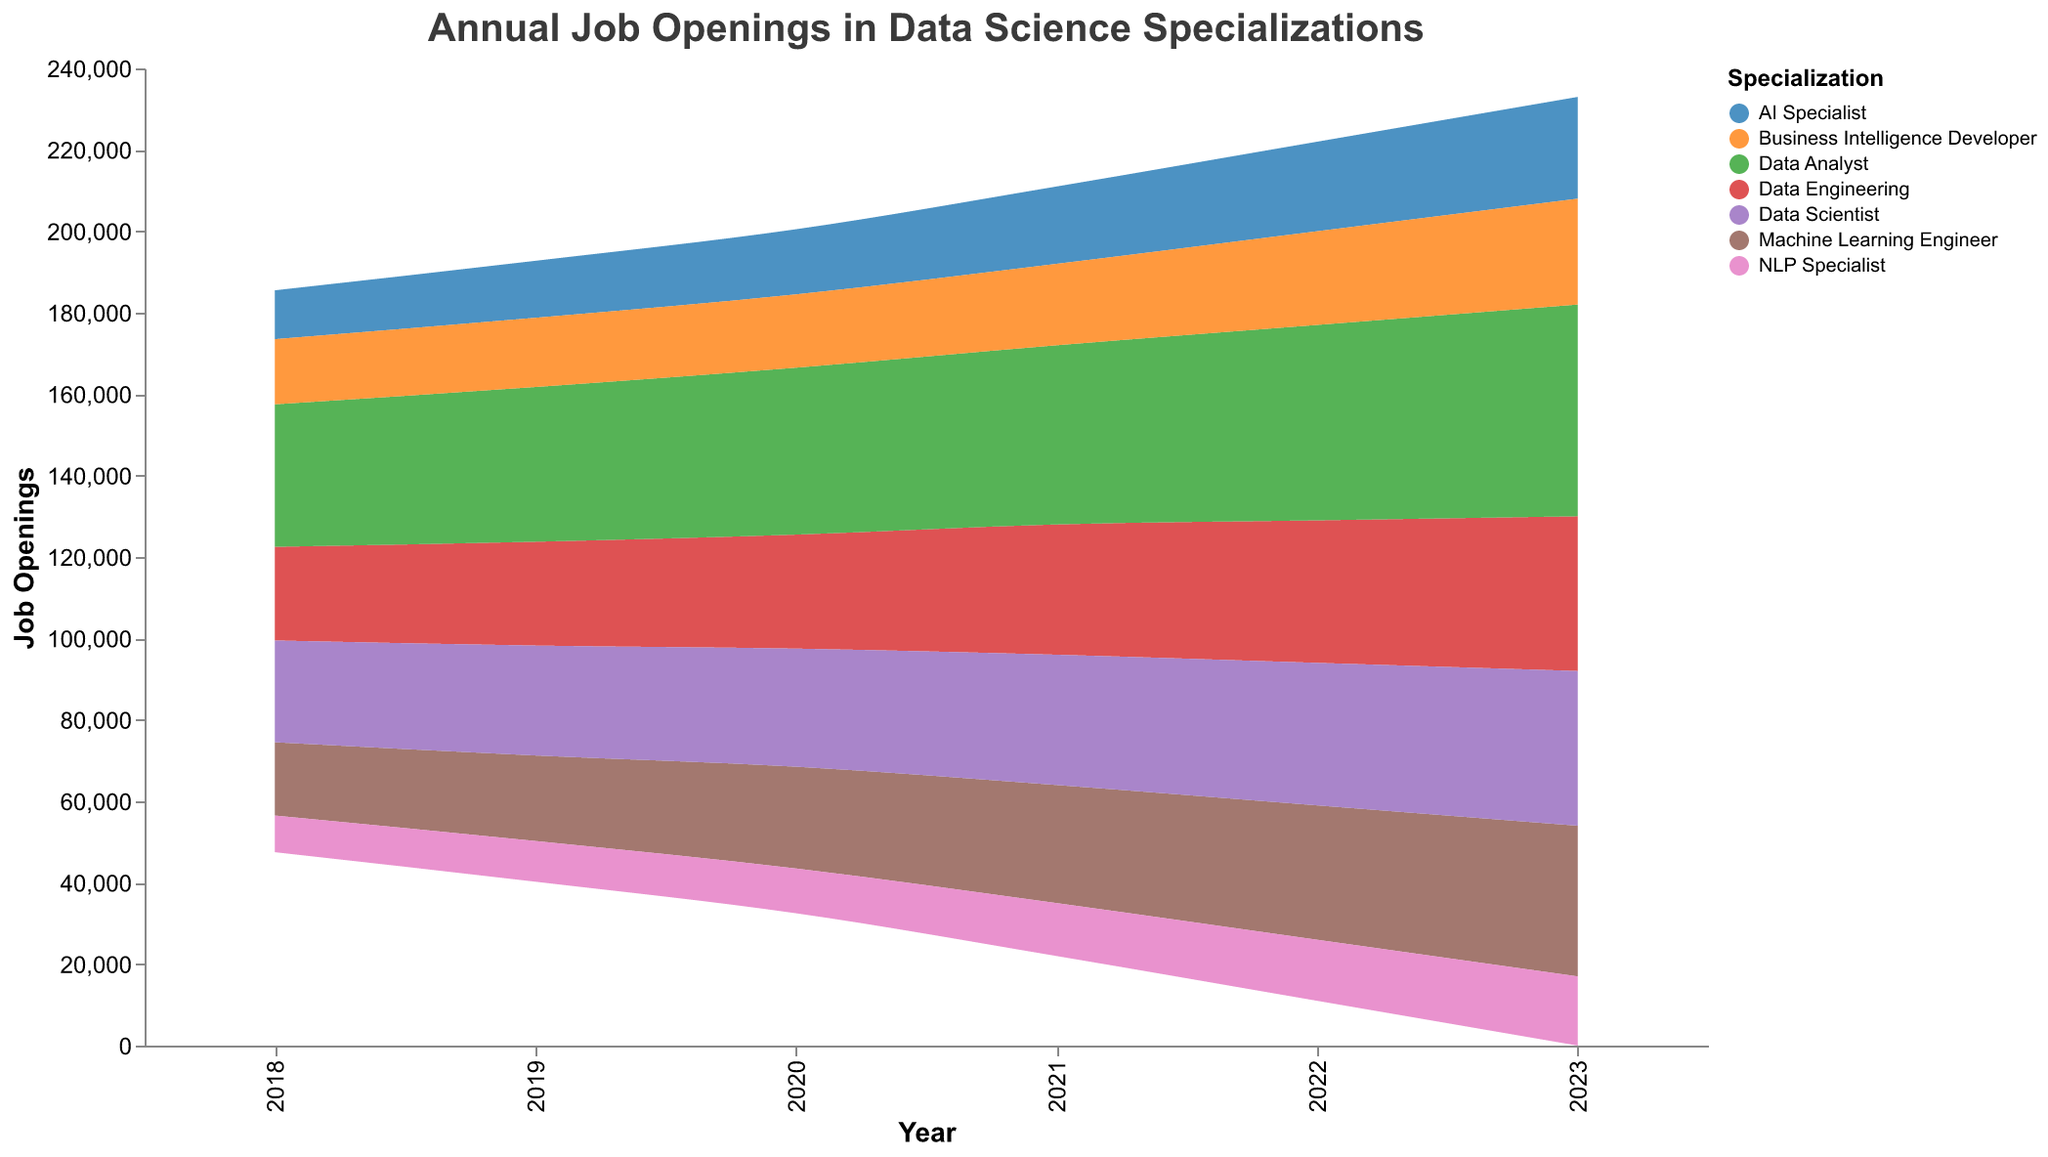What is the title of the figure? The title is often written at the top of the figure with large and bold font. In this case, it reads "Annual Job Openings in Data Science Specializations".
Answer: Annual Job Openings in Data Science Specializations Which specialization had the highest number of job openings in 2023? The different color bands represent different specializations, and their heights indicate the number of job openings. In 2023, the Data Analyst specialization has the largest area, indicating the highest number of job openings.
Answer: Data Analyst How has the job opening trend for AI Specialists changed from 2018 to 2023? By following the color band representing AI Specialists from 2018 to 2023, we see a steady increase. This can be verified by the visualization's upward trend for the AI Specialist color band.
Answer: Increased Compare the job openings for Data Engineers and Data Scientists in 2021. Which one is higher? Locate the two color bands for Data Engineers and Data Scientists in 2021. The color band for Data Science is slightly higher than Data Engineering, indicating more job openings.
Answer: Data Scientist Calculate the total number of job openings for all specializations in 2022? Sum up the values for all specializations in the year 2022 from the figure. The values are: Data Engineering (35,000), Machine Learning Engineer (33,000), Data Analyst (48,000), Data Scientist (35,000), AI Specialist (22,000), NLP Specialist (15,000), Business Intelligence Developer (23,000). Adding these, the total is 211,000.
Answer: 211,000 How did the relative growth rate for Data Engineers compare to that for NLP Specialists from 2021 to 2022? Check the growth rates for Data Engineers and NLP Specialists from 2021 to 2022. Data Engineers had a growth rate of 9.38%, while NLP Specialists had a growth rate of 15.38%. NLP Specialists had a higher growth rate.
Answer: NLP Specialists had a higher growth rate Which specialization had the lowest growth rate in 2020? The year-to-year growth rates for each specialization are provided. For 2020, the lowest growth rate can be observed for Business Intelligence Developer, which had only a 5.88% growth rate.
Answer: Business Intelligence Developer What is the difference in job openings between Data Analysts and Machine Learning Engineers in 2019? Locate the Data Analyst and Machine Learning Engineer job openings for 2019. Subtract the number of job openings for Machine Learning Engineer (21,000) from the number for Data Analyst (38,000). The difference is 17,000.
Answer: 17,000 Which specialization sees the most consistent growth in job openings from 2018 to 2023? By visually examining the color bands over the years from 2018 to 2023, Machine Learning Engineers exhibit a consistent growth pattern with annual increases.
Answer: Machine Learning Engineer How does the visual area of the AI Specialist band in 2018 compare to 2023? Compare the height and width of the AI Specialist color band between 2018 and 2023. The visual area in 2023 is much larger, indicating an increase in job openings over time.
Answer: Larger in 2023 